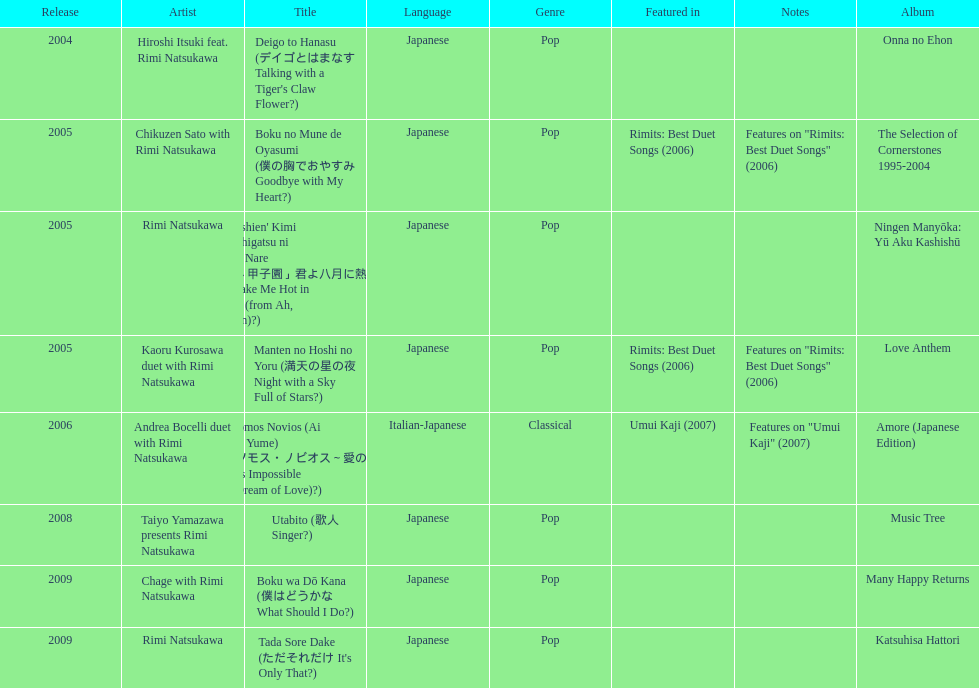What is the last title released? 2009. 